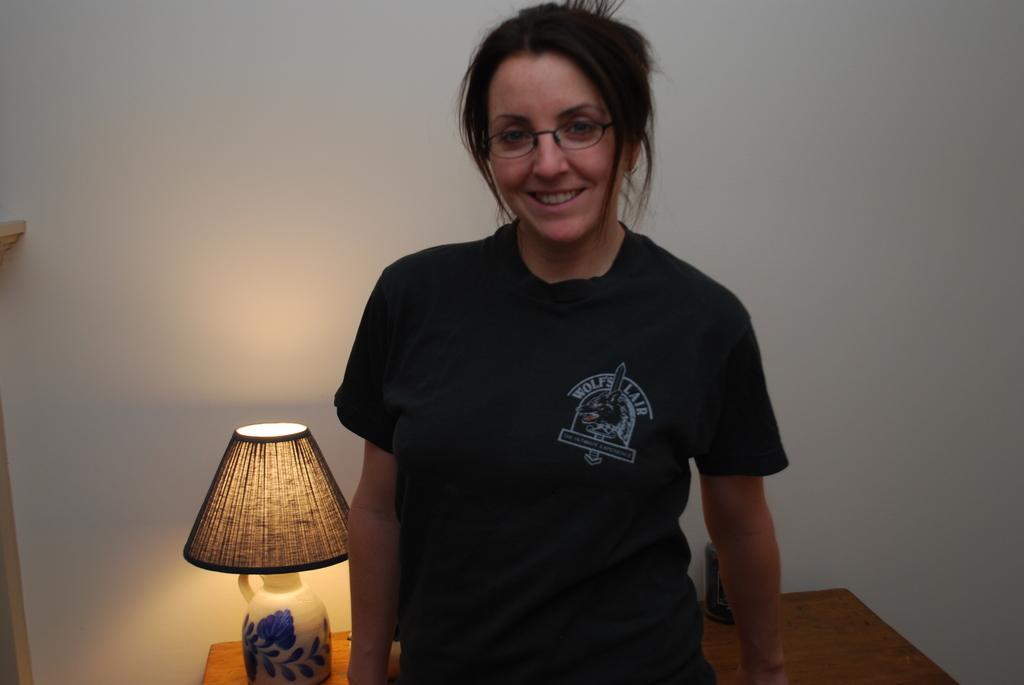In one or two sentences, can you explain what this image depicts? In this image we can see one woman in black T-shirt wearing spectacles, standing and smiling. There is one table lamp on the table, two objects on the table behind the woman, two objects on the left side of the image and there is a white wall in the background. 